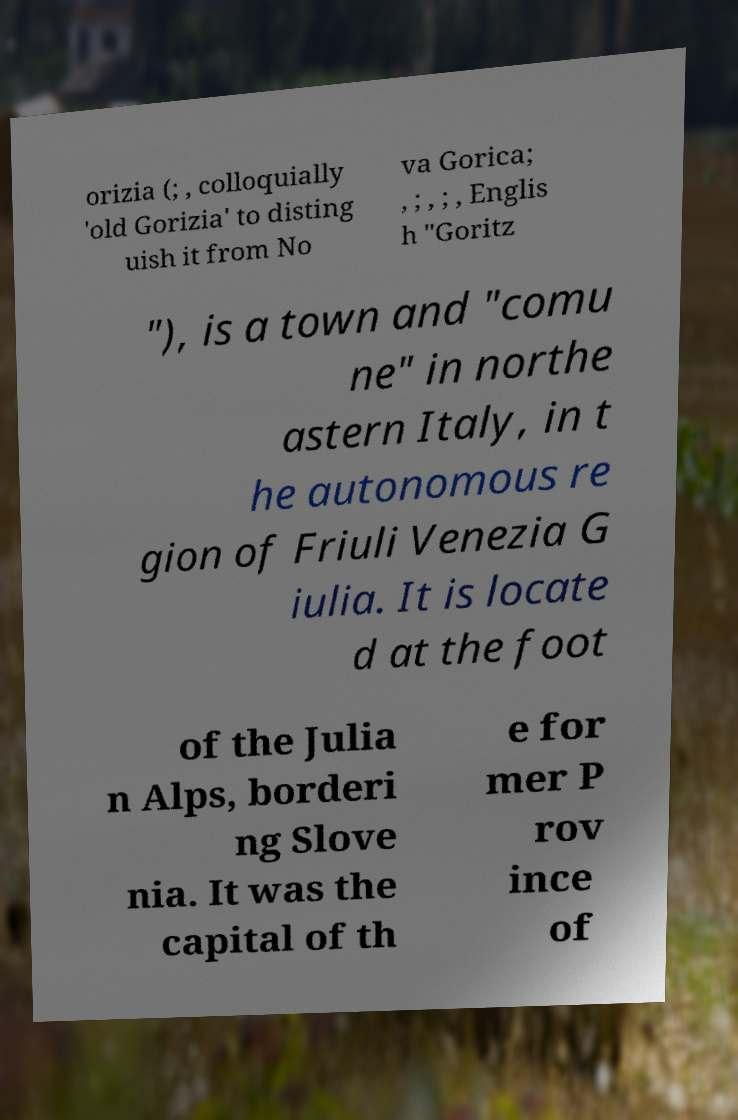For documentation purposes, I need the text within this image transcribed. Could you provide that? orizia (; , colloquially 'old Gorizia' to disting uish it from No va Gorica; , ; , ; , Englis h "Goritz "), is a town and "comu ne" in northe astern Italy, in t he autonomous re gion of Friuli Venezia G iulia. It is locate d at the foot of the Julia n Alps, borderi ng Slove nia. It was the capital of th e for mer P rov ince of 